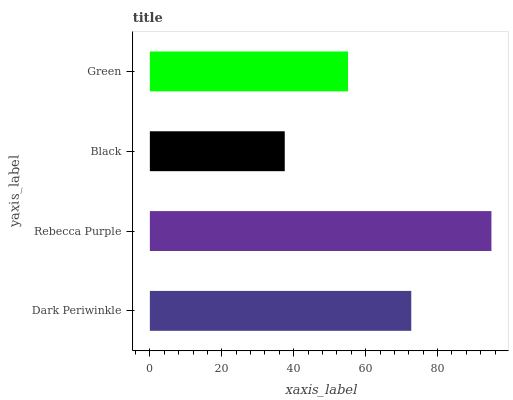Is Black the minimum?
Answer yes or no. Yes. Is Rebecca Purple the maximum?
Answer yes or no. Yes. Is Rebecca Purple the minimum?
Answer yes or no. No. Is Black the maximum?
Answer yes or no. No. Is Rebecca Purple greater than Black?
Answer yes or no. Yes. Is Black less than Rebecca Purple?
Answer yes or no. Yes. Is Black greater than Rebecca Purple?
Answer yes or no. No. Is Rebecca Purple less than Black?
Answer yes or no. No. Is Dark Periwinkle the high median?
Answer yes or no. Yes. Is Green the low median?
Answer yes or no. Yes. Is Green the high median?
Answer yes or no. No. Is Dark Periwinkle the low median?
Answer yes or no. No. 